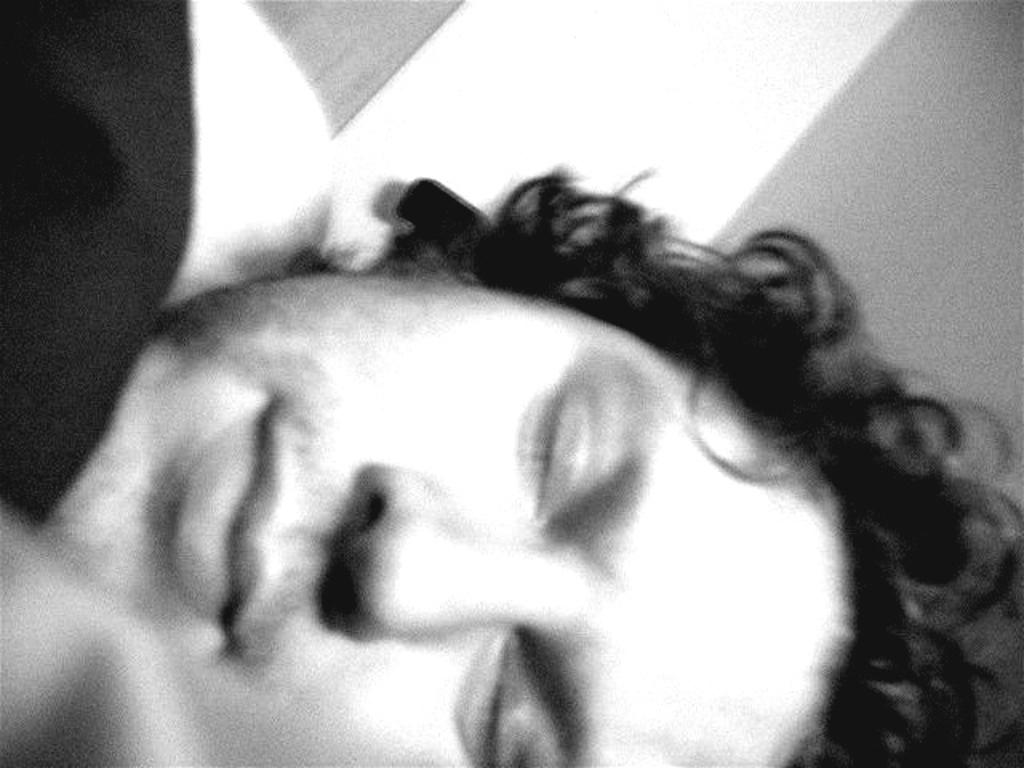What is the main subject of the image? There is a person's face in the image. Are there any cobwebs visible in the image? There is no mention of cobwebs in the provided facts, and therefore it cannot be determined if any are present in the image. 